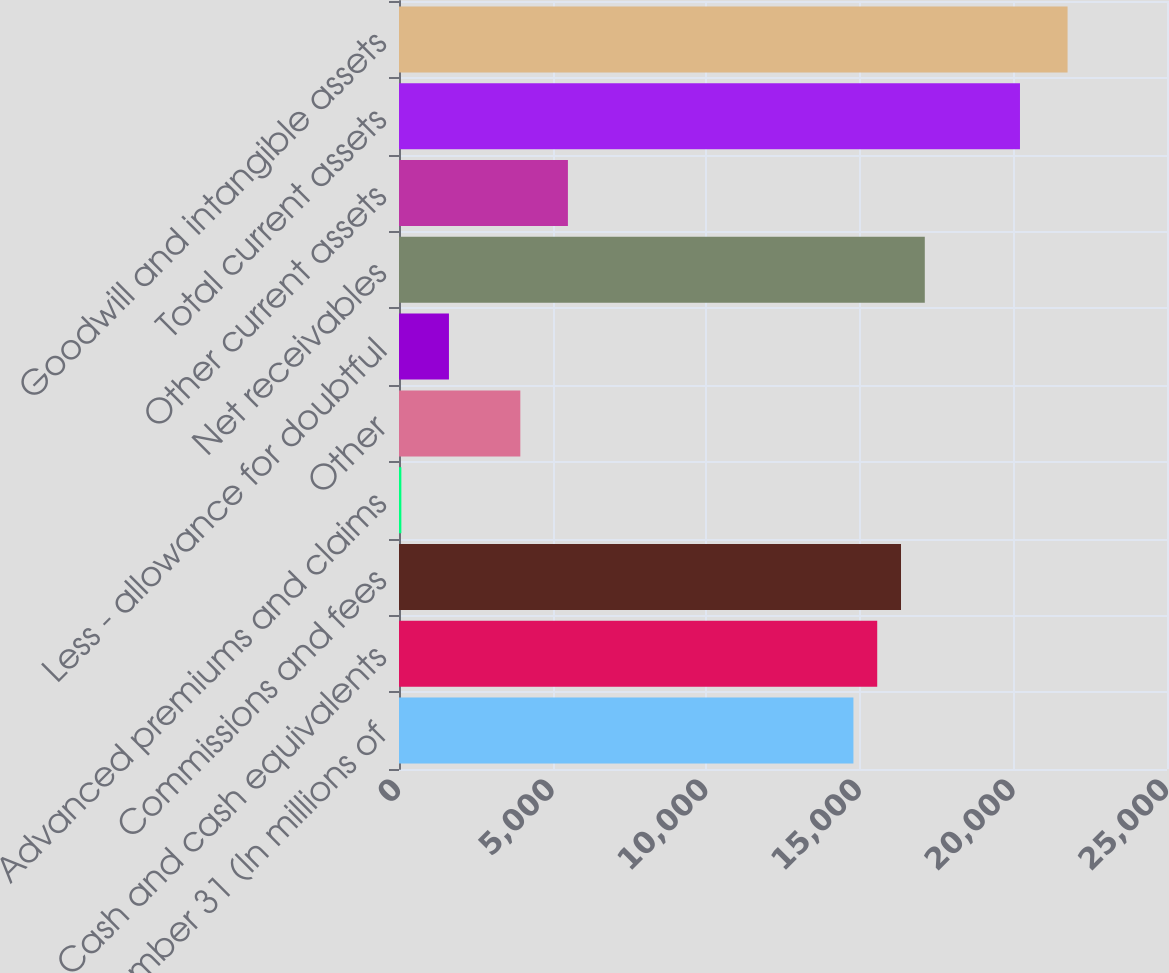Convert chart to OTSL. <chart><loc_0><loc_0><loc_500><loc_500><bar_chart><fcel>December 31 (In millions of<fcel>Cash and cash equivalents<fcel>Commissions and fees<fcel>Advanced premiums and claims<fcel>Other<fcel>Less - allowance for doubtful<fcel>Net receivables<fcel>Other current assets<fcel>Total current assets<fcel>Goodwill and intangible assets<nl><fcel>14792.5<fcel>15567<fcel>16341.5<fcel>77<fcel>3949.5<fcel>1626<fcel>17116<fcel>5498.5<fcel>20214<fcel>21763<nl></chart> 